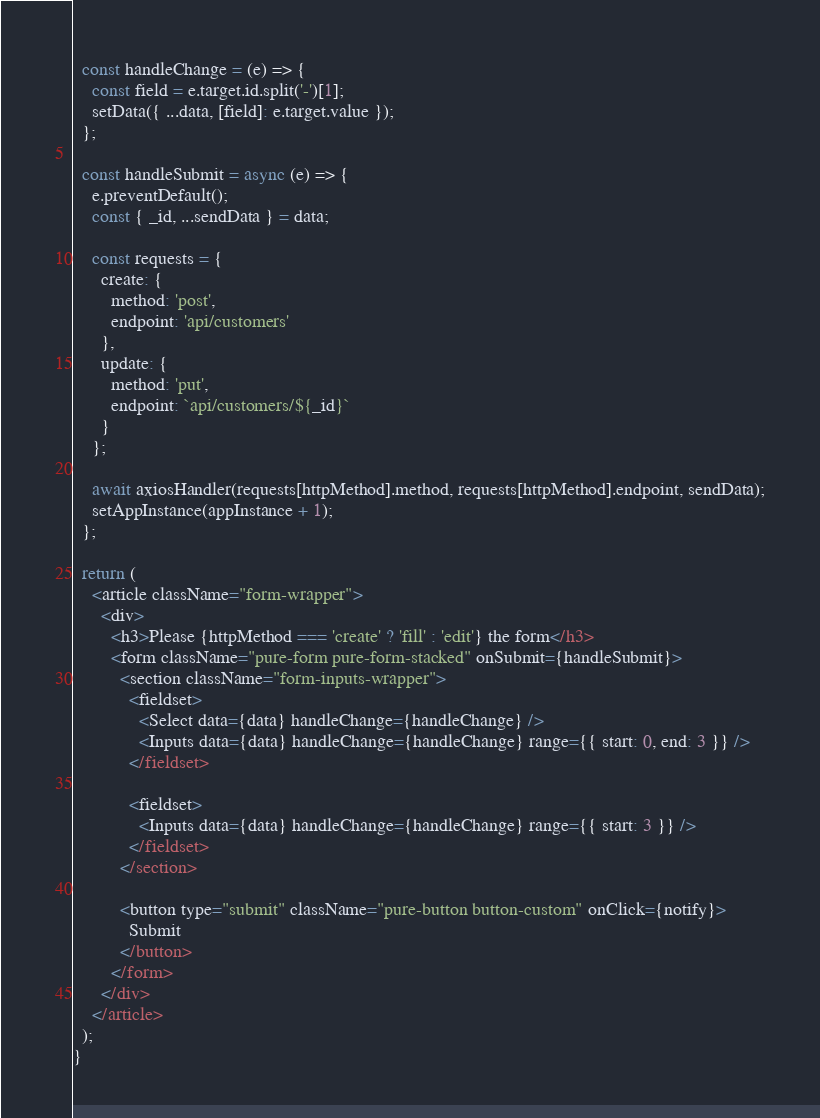<code> <loc_0><loc_0><loc_500><loc_500><_JavaScript_>  const handleChange = (e) => {
    const field = e.target.id.split('-')[1];
    setData({ ...data, [field]: e.target.value });
  };

  const handleSubmit = async (e) => {
    e.preventDefault();
    const { _id, ...sendData } = data;

    const requests = {
      create: {
        method: 'post',
        endpoint: 'api/customers'
      },
      update: {
        method: 'put',
        endpoint: `api/customers/${_id}`
      }
    };

    await axiosHandler(requests[httpMethod].method, requests[httpMethod].endpoint, sendData);
    setAppInstance(appInstance + 1);
  };

  return (
    <article className="form-wrapper">
      <div>
        <h3>Please {httpMethod === 'create' ? 'fill' : 'edit'} the form</h3>
        <form className="pure-form pure-form-stacked" onSubmit={handleSubmit}>
          <section className="form-inputs-wrapper">
            <fieldset>
              <Select data={data} handleChange={handleChange} />
              <Inputs data={data} handleChange={handleChange} range={{ start: 0, end: 3 }} />
            </fieldset>

            <fieldset>
              <Inputs data={data} handleChange={handleChange} range={{ start: 3 }} />
            </fieldset>
          </section>

          <button type="submit" className="pure-button button-custom" onClick={notify}>
            Submit
          </button>
        </form>
      </div>
    </article>
  );
}
</code> 